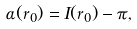<formula> <loc_0><loc_0><loc_500><loc_500>\alpha ( r _ { 0 } ) = I ( r _ { 0 } ) - \pi ,</formula> 